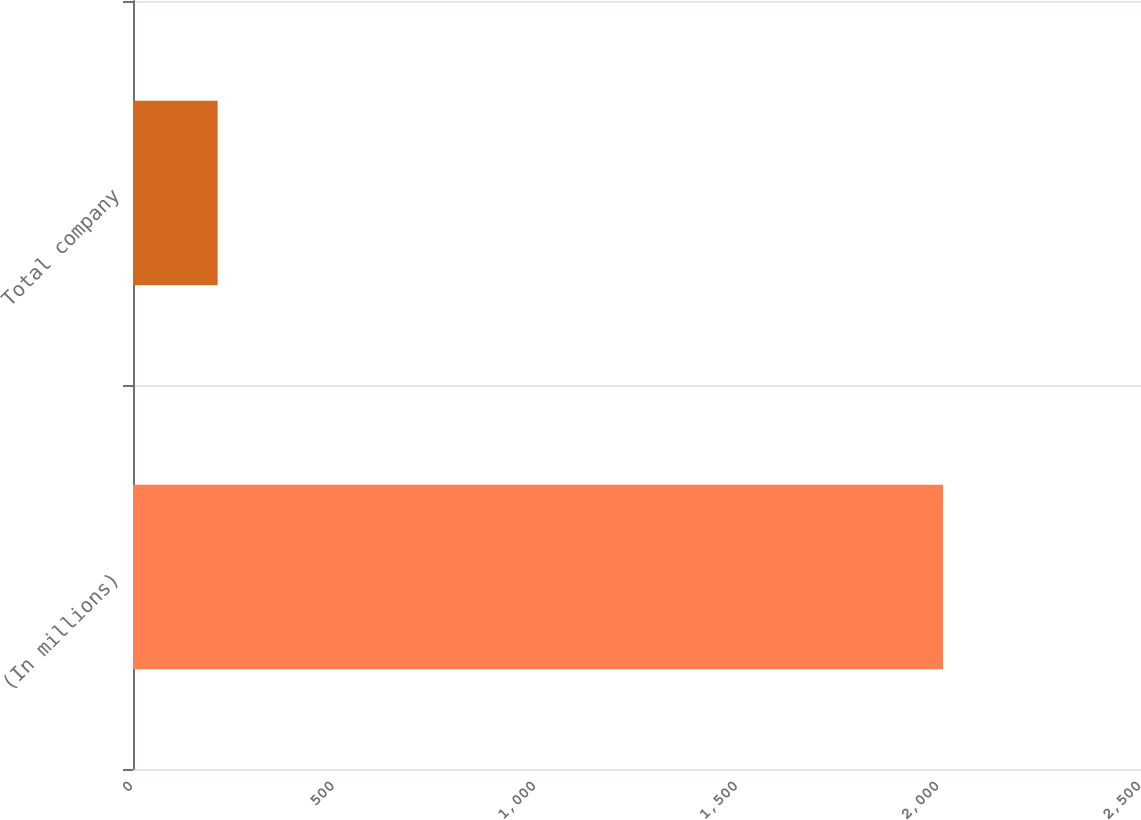Convert chart. <chart><loc_0><loc_0><loc_500><loc_500><bar_chart><fcel>(In millions)<fcel>Total company<nl><fcel>2009<fcel>210<nl></chart> 